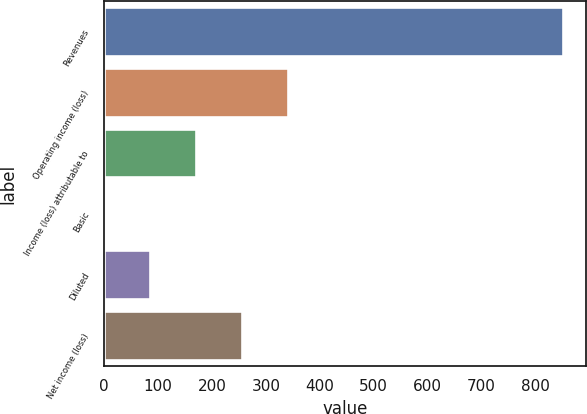Convert chart. <chart><loc_0><loc_0><loc_500><loc_500><bar_chart><fcel>Revenues<fcel>Operating income (loss)<fcel>Income (loss) attributable to<fcel>Basic<fcel>Diluted<fcel>Net income (loss)<nl><fcel>851<fcel>340.75<fcel>170.67<fcel>0.59<fcel>85.63<fcel>255.71<nl></chart> 